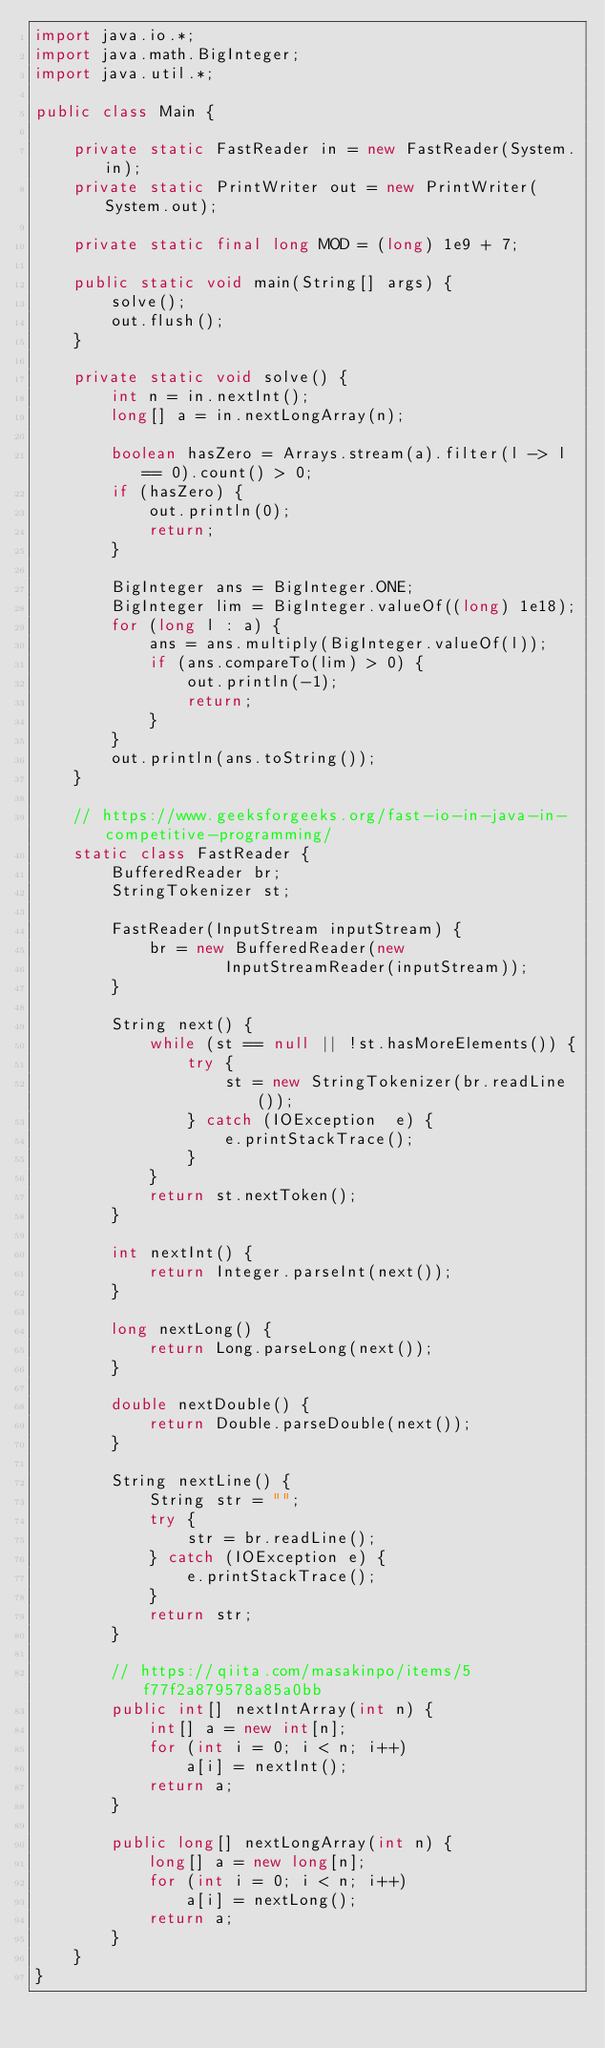Convert code to text. <code><loc_0><loc_0><loc_500><loc_500><_Java_>import java.io.*;
import java.math.BigInteger;
import java.util.*;

public class Main {

    private static FastReader in = new FastReader(System.in);
    private static PrintWriter out = new PrintWriter(System.out);

    private static final long MOD = (long) 1e9 + 7;

    public static void main(String[] args) {
        solve();
        out.flush();
    }

    private static void solve() {
        int n = in.nextInt();
        long[] a = in.nextLongArray(n);

        boolean hasZero = Arrays.stream(a).filter(l -> l == 0).count() > 0;
        if (hasZero) {
            out.println(0);
            return;
        }

        BigInteger ans = BigInteger.ONE;
        BigInteger lim = BigInteger.valueOf((long) 1e18);
        for (long l : a) {
            ans = ans.multiply(BigInteger.valueOf(l));
            if (ans.compareTo(lim) > 0) {
                out.println(-1);
                return;
            }
        }
        out.println(ans.toString());
    }

    // https://www.geeksforgeeks.org/fast-io-in-java-in-competitive-programming/
    static class FastReader {
        BufferedReader br;
        StringTokenizer st;

        FastReader(InputStream inputStream) {
            br = new BufferedReader(new
                    InputStreamReader(inputStream));
        }

        String next() {
            while (st == null || !st.hasMoreElements()) {
                try {
                    st = new StringTokenizer(br.readLine());
                } catch (IOException  e) {
                    e.printStackTrace();
                }
            }
            return st.nextToken();
        }

        int nextInt() {
            return Integer.parseInt(next());
        }

        long nextLong() {
            return Long.parseLong(next());
        }

        double nextDouble() {
            return Double.parseDouble(next());
        }

        String nextLine() {
            String str = "";
            try {
                str = br.readLine();
            } catch (IOException e) {
                e.printStackTrace();
            }
            return str;
        }

        // https://qiita.com/masakinpo/items/5f77f2a879578a85a0bb
        public int[] nextIntArray(int n) {
            int[] a = new int[n];
            for (int i = 0; i < n; i++)
                a[i] = nextInt();
            return a;
        }

        public long[] nextLongArray(int n) {
            long[] a = new long[n];
            for (int i = 0; i < n; i++)
                a[i] = nextLong();
            return a;
        }
    }
}
</code> 